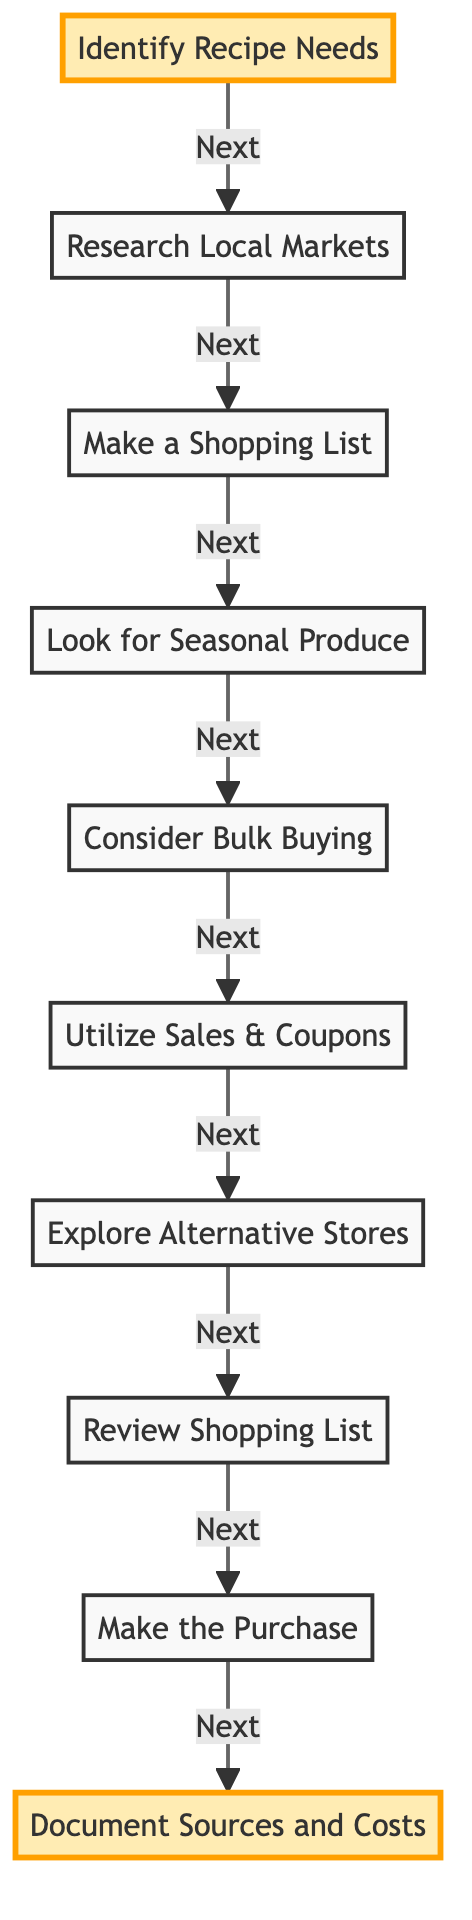What's the first step in the sourcing process? The first step, as indicated in the diagram, is to "Identify Recipe Needs". This is located at the very top of the flowchart and is highlighted for emphasis.
Answer: Identify Recipe Needs How many total steps are in the flowchart? The flowchart lists ten steps in total when counting from "Identify Recipe Needs" to "Document Sources and Costs". Each step is displayed in a sequential manner, leading to the final step.
Answer: Ten What step comes after "Utilize Sales & Coupons"? Following "Utilize Sales & Coupons", the next step according to the diagram is "Explore Alternative Stores". This is determined by tracing the flow from one node to the next.
Answer: Explore Alternative Stores What is the main action in the last step of the flowchart? The last action described in the flowchart is to "Document Sources and Costs". This is shown as the final step and signifies the culmination of the sourcing process.
Answer: Document Sources and Costs Which step focuses on fresh ingredients? The step that emphasizes purchasing fresh ingredients is "Look for Seasonal Produce". This step is positioned to encourage selecting ingredients that are currently in season for better pricing and quality.
Answer: Look for Seasonal Produce What is the primary goal of the entire flowchart? The overall goal of the diagram is to provide systematic steps to source affordable ingredients effectively. Each step builds upon the previous one to achieve this aim.
Answer: Sourcing affordable ingredients What are the two highlighted steps in the flowchart? The two highlighted steps in the flowchart are "Identify Recipe Needs" and "Document Sources and Costs". These steps stand out due to their visual emphasis, indicating their importance in the process.
Answer: Identify Recipe Needs, Document Sources and Costs What does "Consider Bulk Buying" encourage? The step "Consider Bulk Buying" encourages evaluating the cost-saving benefits of purchasing ingredients in larger quantities, typically from wholesale or cooperative outlets.
Answer: Cost-saving benefits What is the next action after reviewing the shopping list? After "Review Shopping List", the next action is "Make the Purchase". This indicates the final preparations before acquiring the ingredients.
Answer: Make the Purchase 